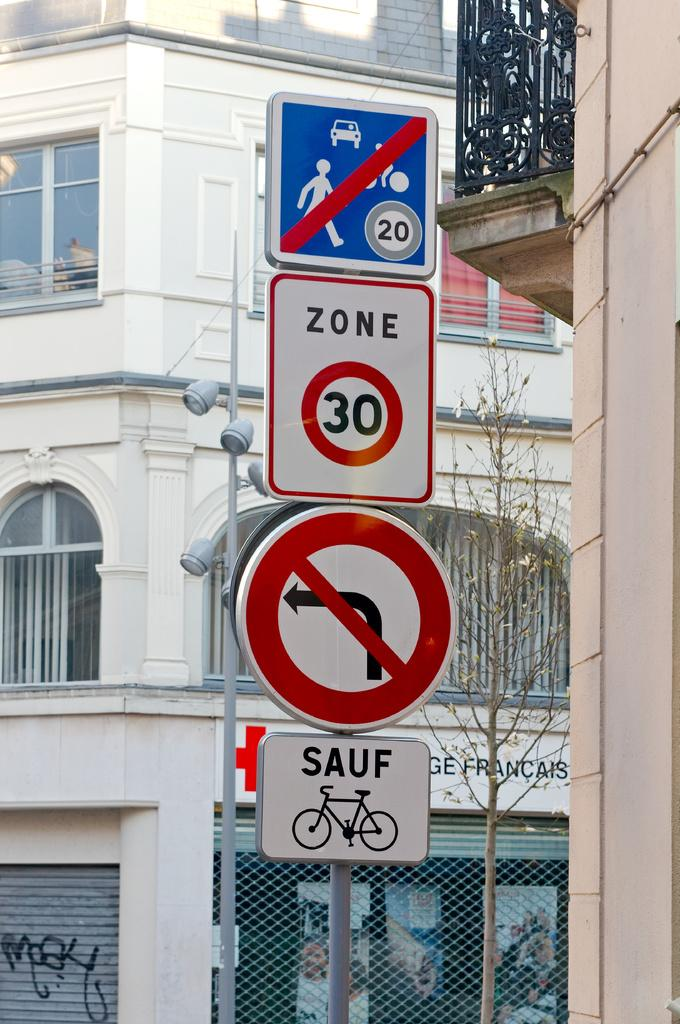Provide a one-sentence caption for the provided image. some street signs that include ZONE 30, Sauf bikes and no left turn. 